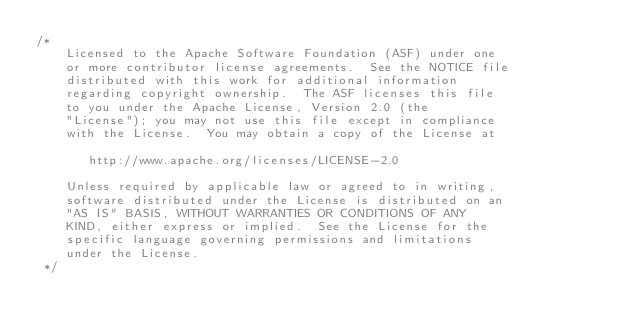Convert code to text. <code><loc_0><loc_0><loc_500><loc_500><_Java_>/* 
    Licensed to the Apache Software Foundation (ASF) under one
    or more contributor license agreements.  See the NOTICE file
    distributed with this work for additional information
    regarding copyright ownership.  The ASF licenses this file
    to you under the Apache License, Version 2.0 (the
    "License"); you may not use this file except in compliance
    with the License.  You may obtain a copy of the License at

       http://www.apache.org/licenses/LICENSE-2.0

    Unless required by applicable law or agreed to in writing,
    software distributed under the License is distributed on an
    "AS IS" BASIS, WITHOUT WARRANTIES OR CONDITIONS OF ANY
    KIND, either express or implied.  See the License for the
    specific language governing permissions and limitations
    under the License.  
 */
</code> 